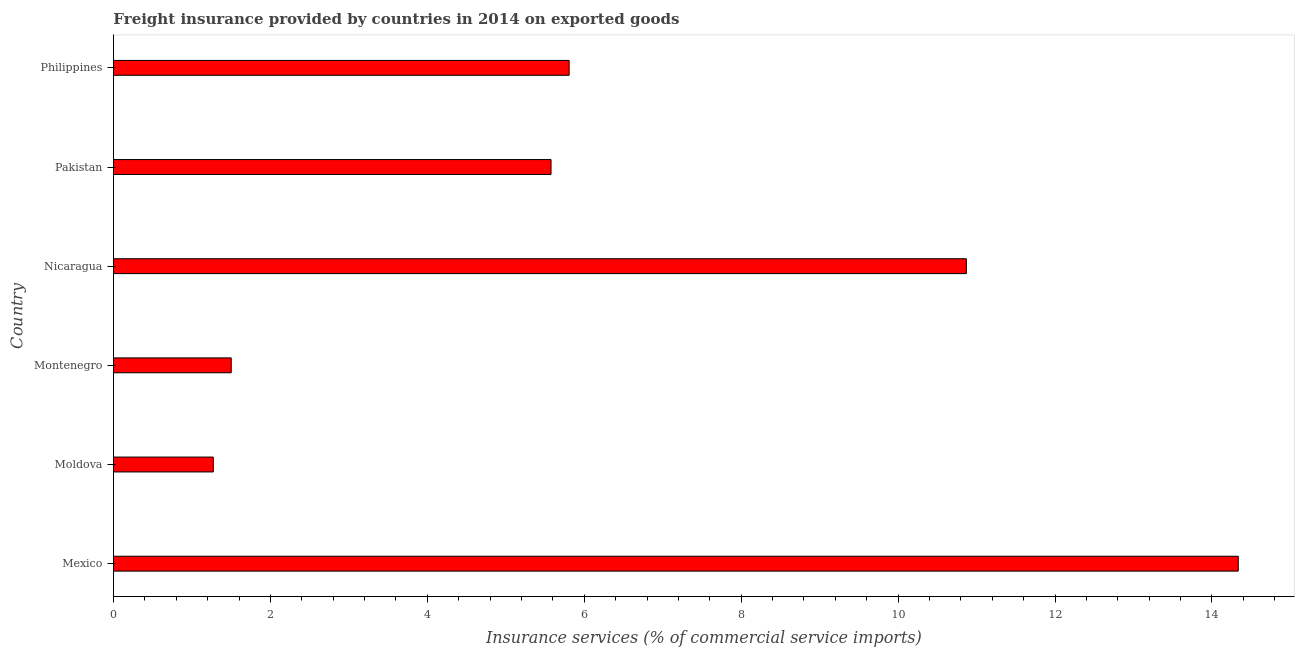Does the graph contain any zero values?
Make the answer very short. No. What is the title of the graph?
Make the answer very short. Freight insurance provided by countries in 2014 on exported goods . What is the label or title of the X-axis?
Provide a short and direct response. Insurance services (% of commercial service imports). What is the freight insurance in Pakistan?
Your answer should be very brief. 5.58. Across all countries, what is the maximum freight insurance?
Your response must be concise. 14.33. Across all countries, what is the minimum freight insurance?
Ensure brevity in your answer.  1.27. In which country was the freight insurance maximum?
Make the answer very short. Mexico. In which country was the freight insurance minimum?
Your answer should be compact. Moldova. What is the sum of the freight insurance?
Give a very brief answer. 39.36. What is the difference between the freight insurance in Moldova and Montenegro?
Keep it short and to the point. -0.23. What is the average freight insurance per country?
Make the answer very short. 6.56. What is the median freight insurance?
Provide a short and direct response. 5.69. What is the ratio of the freight insurance in Montenegro to that in Philippines?
Offer a very short reply. 0.26. Is the freight insurance in Pakistan less than that in Philippines?
Offer a terse response. Yes. What is the difference between the highest and the second highest freight insurance?
Ensure brevity in your answer.  3.46. Is the sum of the freight insurance in Montenegro and Philippines greater than the maximum freight insurance across all countries?
Keep it short and to the point. No. What is the difference between the highest and the lowest freight insurance?
Your answer should be very brief. 13.06. In how many countries, is the freight insurance greater than the average freight insurance taken over all countries?
Your answer should be very brief. 2. Are all the bars in the graph horizontal?
Your response must be concise. Yes. How many countries are there in the graph?
Your response must be concise. 6. What is the difference between two consecutive major ticks on the X-axis?
Offer a very short reply. 2. What is the Insurance services (% of commercial service imports) in Mexico?
Offer a terse response. 14.33. What is the Insurance services (% of commercial service imports) in Moldova?
Keep it short and to the point. 1.27. What is the Insurance services (% of commercial service imports) of Montenegro?
Your answer should be compact. 1.5. What is the Insurance services (% of commercial service imports) of Nicaragua?
Offer a terse response. 10.87. What is the Insurance services (% of commercial service imports) in Pakistan?
Your answer should be very brief. 5.58. What is the Insurance services (% of commercial service imports) of Philippines?
Make the answer very short. 5.81. What is the difference between the Insurance services (% of commercial service imports) in Mexico and Moldova?
Offer a terse response. 13.06. What is the difference between the Insurance services (% of commercial service imports) in Mexico and Montenegro?
Give a very brief answer. 12.83. What is the difference between the Insurance services (% of commercial service imports) in Mexico and Nicaragua?
Provide a short and direct response. 3.47. What is the difference between the Insurance services (% of commercial service imports) in Mexico and Pakistan?
Offer a terse response. 8.76. What is the difference between the Insurance services (% of commercial service imports) in Mexico and Philippines?
Ensure brevity in your answer.  8.53. What is the difference between the Insurance services (% of commercial service imports) in Moldova and Montenegro?
Give a very brief answer. -0.23. What is the difference between the Insurance services (% of commercial service imports) in Moldova and Nicaragua?
Give a very brief answer. -9.6. What is the difference between the Insurance services (% of commercial service imports) in Moldova and Pakistan?
Offer a terse response. -4.3. What is the difference between the Insurance services (% of commercial service imports) in Moldova and Philippines?
Provide a short and direct response. -4.54. What is the difference between the Insurance services (% of commercial service imports) in Montenegro and Nicaragua?
Keep it short and to the point. -9.37. What is the difference between the Insurance services (% of commercial service imports) in Montenegro and Pakistan?
Keep it short and to the point. -4.08. What is the difference between the Insurance services (% of commercial service imports) in Montenegro and Philippines?
Offer a very short reply. -4.31. What is the difference between the Insurance services (% of commercial service imports) in Nicaragua and Pakistan?
Ensure brevity in your answer.  5.29. What is the difference between the Insurance services (% of commercial service imports) in Nicaragua and Philippines?
Keep it short and to the point. 5.06. What is the difference between the Insurance services (% of commercial service imports) in Pakistan and Philippines?
Your response must be concise. -0.23. What is the ratio of the Insurance services (% of commercial service imports) in Mexico to that in Moldova?
Your response must be concise. 11.27. What is the ratio of the Insurance services (% of commercial service imports) in Mexico to that in Montenegro?
Your answer should be very brief. 9.55. What is the ratio of the Insurance services (% of commercial service imports) in Mexico to that in Nicaragua?
Give a very brief answer. 1.32. What is the ratio of the Insurance services (% of commercial service imports) in Mexico to that in Pakistan?
Your answer should be very brief. 2.57. What is the ratio of the Insurance services (% of commercial service imports) in Mexico to that in Philippines?
Make the answer very short. 2.47. What is the ratio of the Insurance services (% of commercial service imports) in Moldova to that in Montenegro?
Give a very brief answer. 0.85. What is the ratio of the Insurance services (% of commercial service imports) in Moldova to that in Nicaragua?
Offer a terse response. 0.12. What is the ratio of the Insurance services (% of commercial service imports) in Moldova to that in Pakistan?
Ensure brevity in your answer.  0.23. What is the ratio of the Insurance services (% of commercial service imports) in Moldova to that in Philippines?
Provide a short and direct response. 0.22. What is the ratio of the Insurance services (% of commercial service imports) in Montenegro to that in Nicaragua?
Keep it short and to the point. 0.14. What is the ratio of the Insurance services (% of commercial service imports) in Montenegro to that in Pakistan?
Provide a succinct answer. 0.27. What is the ratio of the Insurance services (% of commercial service imports) in Montenegro to that in Philippines?
Your response must be concise. 0.26. What is the ratio of the Insurance services (% of commercial service imports) in Nicaragua to that in Pakistan?
Keep it short and to the point. 1.95. What is the ratio of the Insurance services (% of commercial service imports) in Nicaragua to that in Philippines?
Offer a very short reply. 1.87. What is the ratio of the Insurance services (% of commercial service imports) in Pakistan to that in Philippines?
Your answer should be very brief. 0.96. 